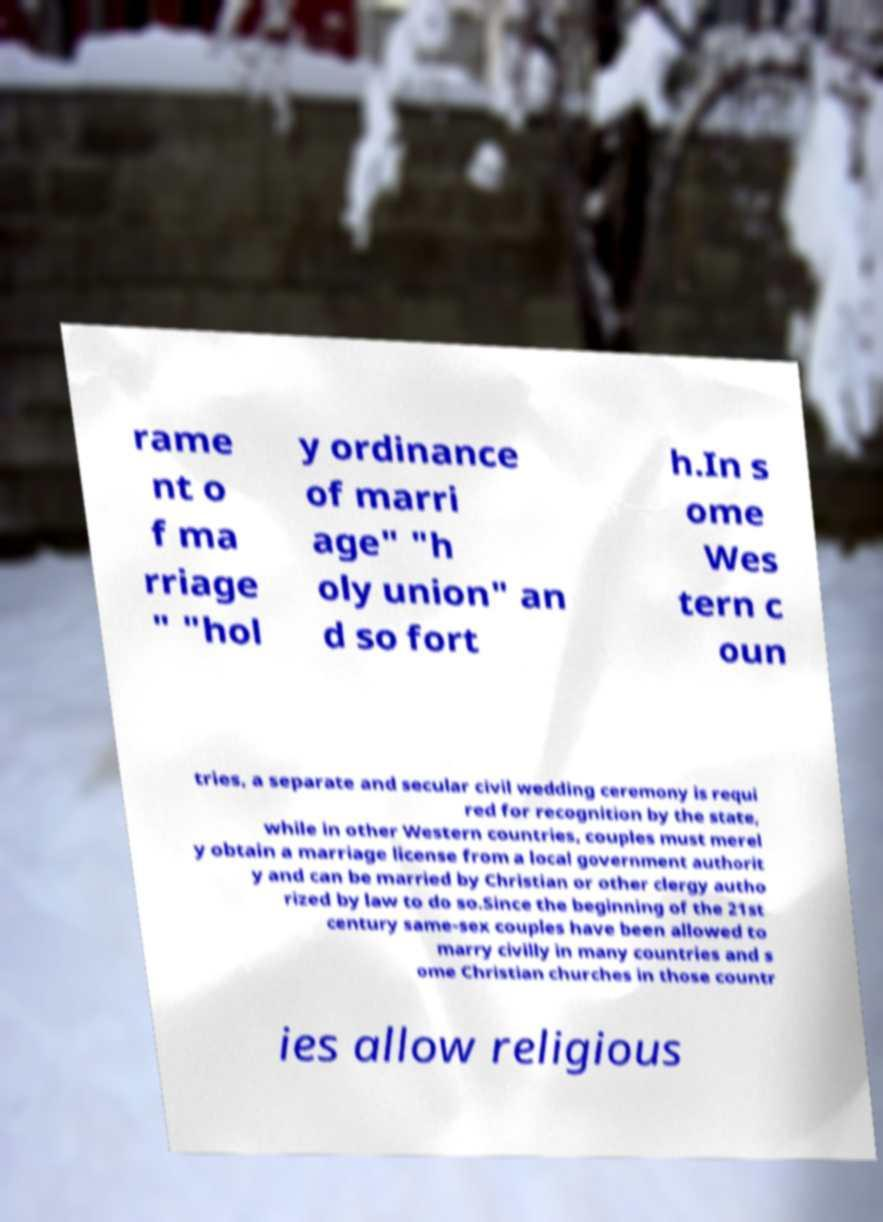I need the written content from this picture converted into text. Can you do that? rame nt o f ma rriage " "hol y ordinance of marri age" "h oly union" an d so fort h.In s ome Wes tern c oun tries, a separate and secular civil wedding ceremony is requi red for recognition by the state, while in other Western countries, couples must merel y obtain a marriage license from a local government authorit y and can be married by Christian or other clergy autho rized by law to do so.Since the beginning of the 21st century same-sex couples have been allowed to marry civilly in many countries and s ome Christian churches in those countr ies allow religious 